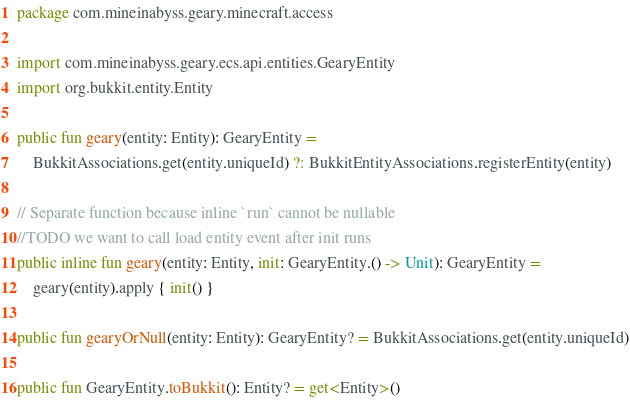<code> <loc_0><loc_0><loc_500><loc_500><_Kotlin_>package com.mineinabyss.geary.minecraft.access

import com.mineinabyss.geary.ecs.api.entities.GearyEntity
import org.bukkit.entity.Entity

public fun geary(entity: Entity): GearyEntity =
    BukkitAssociations.get(entity.uniqueId) ?: BukkitEntityAssociations.registerEntity(entity)

// Separate function because inline `run` cannot be nullable
//TODO we want to call load entity event after init runs
public inline fun geary(entity: Entity, init: GearyEntity.() -> Unit): GearyEntity =
    geary(entity).apply { init() }

public fun gearyOrNull(entity: Entity): GearyEntity? = BukkitAssociations.get(entity.uniqueId)

public fun GearyEntity.toBukkit(): Entity? = get<Entity>()
</code> 